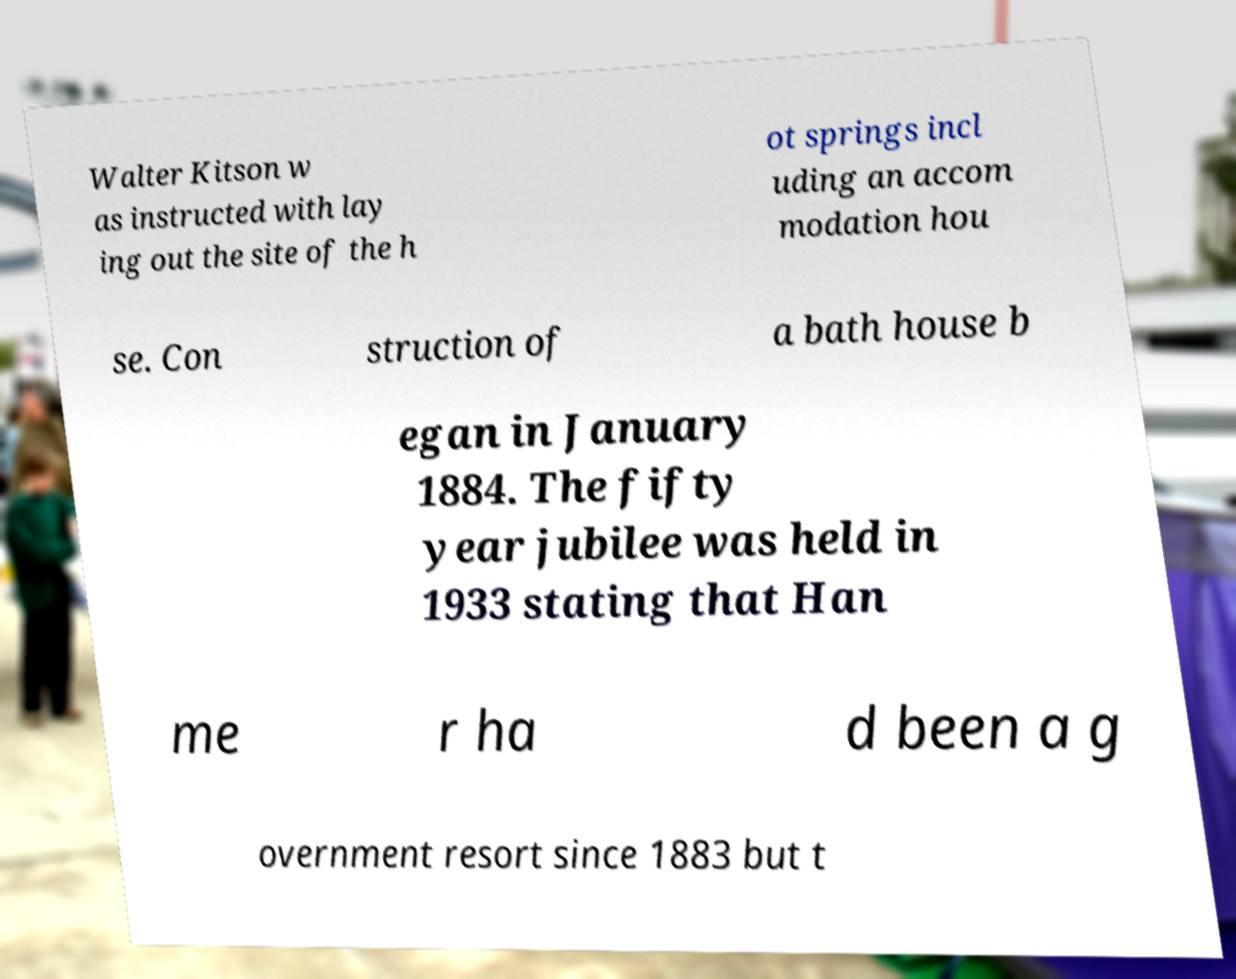I need the written content from this picture converted into text. Can you do that? Walter Kitson w as instructed with lay ing out the site of the h ot springs incl uding an accom modation hou se. Con struction of a bath house b egan in January 1884. The fifty year jubilee was held in 1933 stating that Han me r ha d been a g overnment resort since 1883 but t 